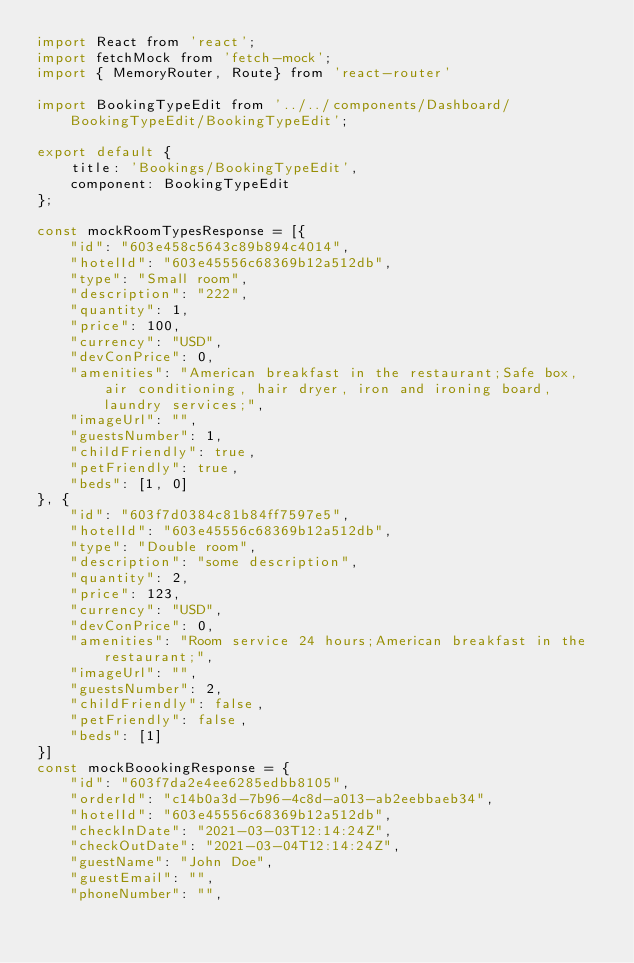Convert code to text. <code><loc_0><loc_0><loc_500><loc_500><_JavaScript_>import React from 'react';
import fetchMock from 'fetch-mock';
import { MemoryRouter, Route} from 'react-router'

import BookingTypeEdit from '../../components/Dashboard/BookingTypeEdit/BookingTypeEdit';

export default {
    title: 'Bookings/BookingTypeEdit',
    component: BookingTypeEdit
};

const mockRoomTypesResponse = [{
    "id": "603e458c5643c89b894c4014",
    "hotelId": "603e45556c68369b12a512db",
    "type": "Small room",
    "description": "222",
    "quantity": 1,
    "price": 100,
    "currency": "USD",
    "devConPrice": 0,
    "amenities": "American breakfast in the restaurant;Safe box, air conditioning, hair dryer, iron and ironing board, laundry services;",
    "imageUrl": "",
    "guestsNumber": 1,
    "childFriendly": true,
    "petFriendly": true,
    "beds": [1, 0]
}, {
    "id": "603f7d0384c81b84ff7597e5",
    "hotelId": "603e45556c68369b12a512db",
    "type": "Double room",
    "description": "some description",
    "quantity": 2,
    "price": 123,
    "currency": "USD",
    "devConPrice": 0,
    "amenities": "Room service 24 hours;American breakfast in the restaurant;",
    "imageUrl": "",
    "guestsNumber": 2,
    "childFriendly": false,
    "petFriendly": false,
    "beds": [1]
}]
const mockBoookingResponse = {
    "id": "603f7da2e4ee6285edbb8105",
    "orderId": "c14b0a3d-7b96-4c8d-a013-ab2eebbaeb34",
    "hotelId": "603e45556c68369b12a512db",
    "checkInDate": "2021-03-03T12:14:24Z",
    "checkOutDate": "2021-03-04T12:14:24Z",
    "guestName": "John Doe",
    "guestEmail": "",
    "phoneNumber": "",</code> 